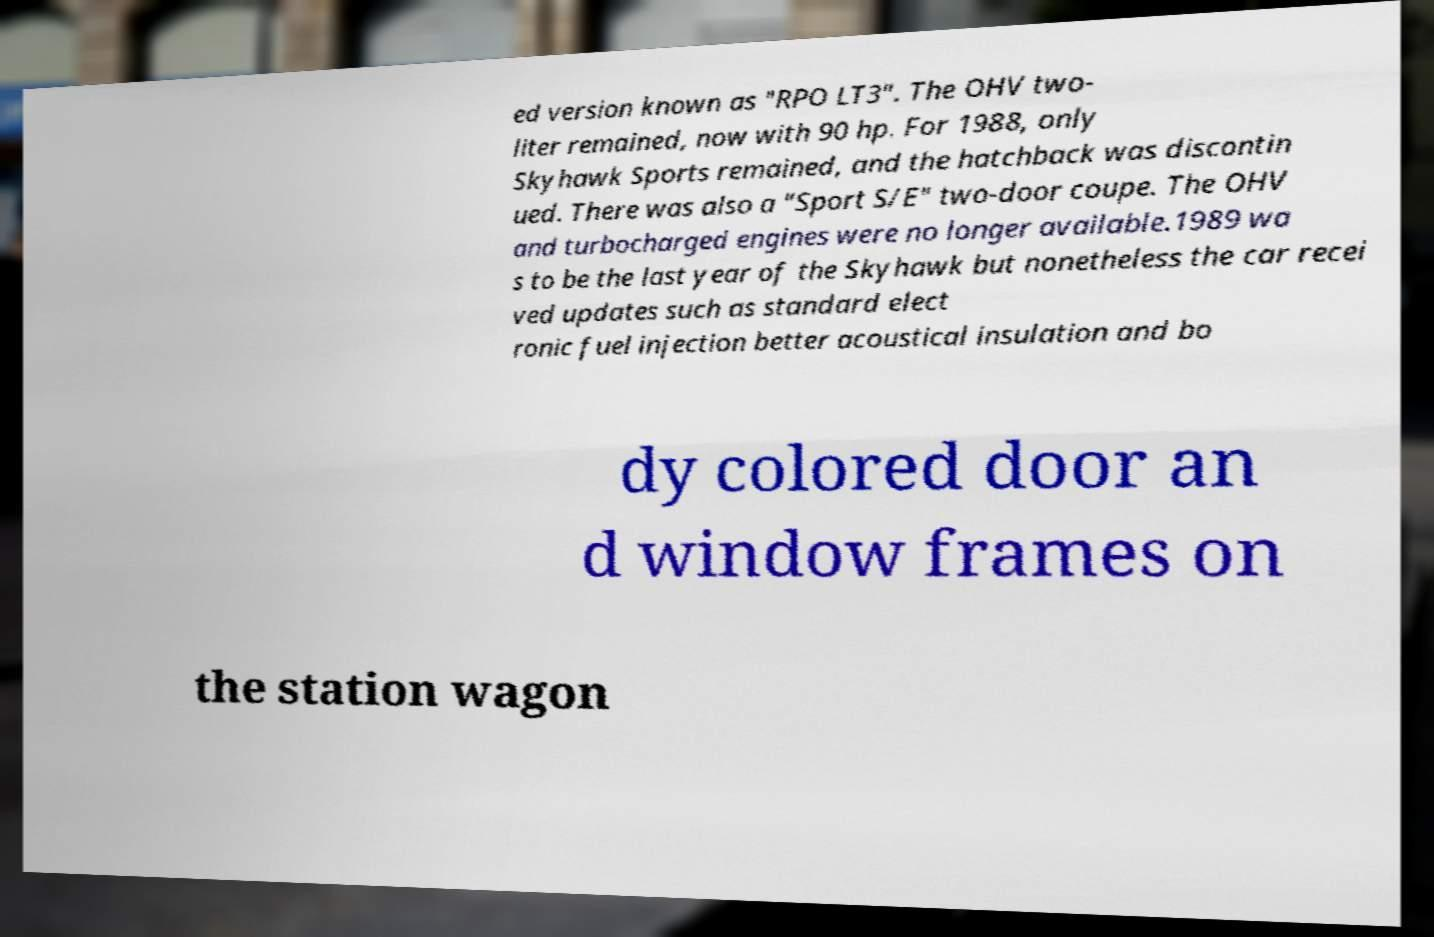I need the written content from this picture converted into text. Can you do that? ed version known as "RPO LT3". The OHV two- liter remained, now with 90 hp. For 1988, only Skyhawk Sports remained, and the hatchback was discontin ued. There was also a "Sport S/E" two-door coupe. The OHV and turbocharged engines were no longer available.1989 wa s to be the last year of the Skyhawk but nonetheless the car recei ved updates such as standard elect ronic fuel injection better acoustical insulation and bo dy colored door an d window frames on the station wagon 